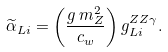Convert formula to latex. <formula><loc_0><loc_0><loc_500><loc_500>\widetilde { \alpha } _ { L i } = \left ( \frac { g \, m _ { Z } ^ { 2 } } { c _ { w } } \right ) g ^ { Z Z \gamma } _ { L i } .</formula> 